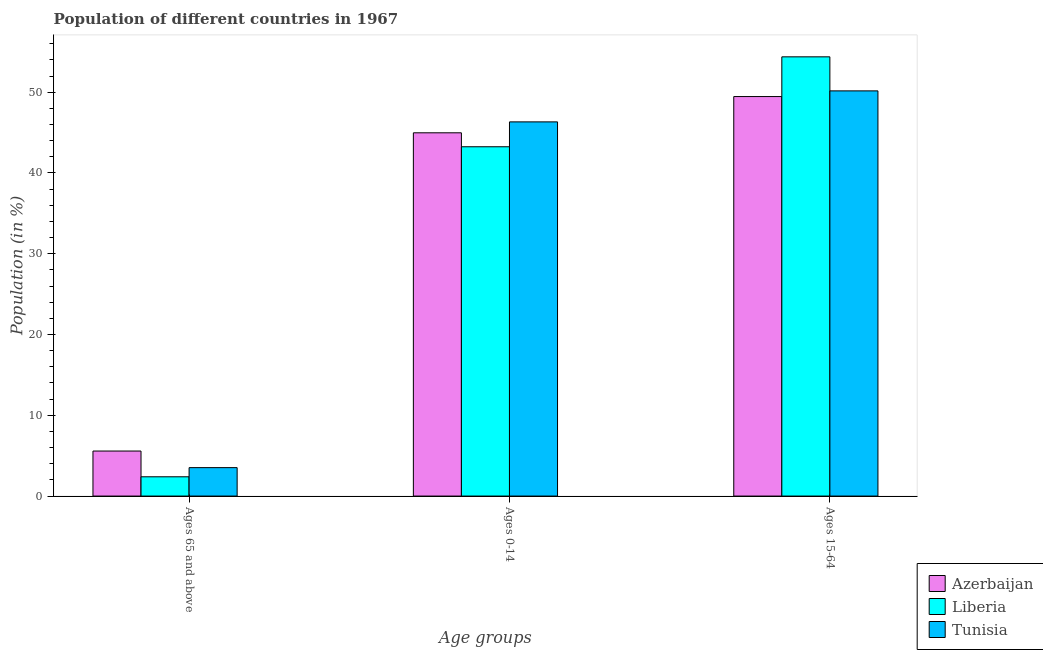How many different coloured bars are there?
Offer a terse response. 3. How many groups of bars are there?
Give a very brief answer. 3. Are the number of bars per tick equal to the number of legend labels?
Your response must be concise. Yes. What is the label of the 1st group of bars from the left?
Your answer should be compact. Ages 65 and above. What is the percentage of population within the age-group 0-14 in Azerbaijan?
Your response must be concise. 44.97. Across all countries, what is the maximum percentage of population within the age-group 15-64?
Give a very brief answer. 54.37. Across all countries, what is the minimum percentage of population within the age-group 0-14?
Provide a succinct answer. 43.24. In which country was the percentage of population within the age-group 15-64 maximum?
Offer a very short reply. Liberia. In which country was the percentage of population within the age-group 0-14 minimum?
Your answer should be very brief. Liberia. What is the total percentage of population within the age-group 0-14 in the graph?
Keep it short and to the point. 134.53. What is the difference between the percentage of population within the age-group 0-14 in Azerbaijan and that in Tunisia?
Keep it short and to the point. -1.35. What is the difference between the percentage of population within the age-group 0-14 in Tunisia and the percentage of population within the age-group of 65 and above in Azerbaijan?
Offer a very short reply. 40.75. What is the average percentage of population within the age-group 15-64 per country?
Make the answer very short. 51.33. What is the difference between the percentage of population within the age-group of 65 and above and percentage of population within the age-group 0-14 in Azerbaijan?
Your answer should be very brief. -39.39. In how many countries, is the percentage of population within the age-group of 65 and above greater than 2 %?
Your answer should be compact. 3. What is the ratio of the percentage of population within the age-group 0-14 in Azerbaijan to that in Liberia?
Your response must be concise. 1.04. Is the percentage of population within the age-group of 65 and above in Tunisia less than that in Liberia?
Your answer should be very brief. No. What is the difference between the highest and the second highest percentage of population within the age-group 15-64?
Your response must be concise. 4.21. What is the difference between the highest and the lowest percentage of population within the age-group of 65 and above?
Give a very brief answer. 3.19. What does the 2nd bar from the left in Ages 0-14 represents?
Provide a short and direct response. Liberia. What does the 1st bar from the right in Ages 0-14 represents?
Your response must be concise. Tunisia. Is it the case that in every country, the sum of the percentage of population within the age-group of 65 and above and percentage of population within the age-group 0-14 is greater than the percentage of population within the age-group 15-64?
Give a very brief answer. No. How many countries are there in the graph?
Offer a terse response. 3. What is the difference between two consecutive major ticks on the Y-axis?
Make the answer very short. 10. Does the graph contain any zero values?
Your answer should be compact. No. Does the graph contain grids?
Make the answer very short. No. Where does the legend appear in the graph?
Provide a short and direct response. Bottom right. What is the title of the graph?
Offer a very short reply. Population of different countries in 1967. Does "Russian Federation" appear as one of the legend labels in the graph?
Offer a terse response. No. What is the label or title of the X-axis?
Your answer should be very brief. Age groups. What is the label or title of the Y-axis?
Offer a very short reply. Population (in %). What is the Population (in %) in Azerbaijan in Ages 65 and above?
Offer a very short reply. 5.57. What is the Population (in %) of Liberia in Ages 65 and above?
Offer a very short reply. 2.39. What is the Population (in %) of Tunisia in Ages 65 and above?
Provide a succinct answer. 3.52. What is the Population (in %) of Azerbaijan in Ages 0-14?
Your response must be concise. 44.97. What is the Population (in %) in Liberia in Ages 0-14?
Make the answer very short. 43.24. What is the Population (in %) in Tunisia in Ages 0-14?
Your response must be concise. 46.32. What is the Population (in %) in Azerbaijan in Ages 15-64?
Your answer should be compact. 49.46. What is the Population (in %) in Liberia in Ages 15-64?
Make the answer very short. 54.37. What is the Population (in %) in Tunisia in Ages 15-64?
Give a very brief answer. 50.16. Across all Age groups, what is the maximum Population (in %) of Azerbaijan?
Offer a very short reply. 49.46. Across all Age groups, what is the maximum Population (in %) of Liberia?
Provide a succinct answer. 54.37. Across all Age groups, what is the maximum Population (in %) of Tunisia?
Your answer should be compact. 50.16. Across all Age groups, what is the minimum Population (in %) in Azerbaijan?
Offer a very short reply. 5.57. Across all Age groups, what is the minimum Population (in %) of Liberia?
Offer a terse response. 2.39. Across all Age groups, what is the minimum Population (in %) in Tunisia?
Make the answer very short. 3.52. What is the total Population (in %) in Azerbaijan in the graph?
Ensure brevity in your answer.  100. What is the total Population (in %) of Liberia in the graph?
Provide a short and direct response. 100. What is the difference between the Population (in %) of Azerbaijan in Ages 65 and above and that in Ages 0-14?
Offer a very short reply. -39.39. What is the difference between the Population (in %) in Liberia in Ages 65 and above and that in Ages 0-14?
Give a very brief answer. -40.86. What is the difference between the Population (in %) of Tunisia in Ages 65 and above and that in Ages 0-14?
Provide a succinct answer. -42.8. What is the difference between the Population (in %) of Azerbaijan in Ages 65 and above and that in Ages 15-64?
Offer a terse response. -43.88. What is the difference between the Population (in %) of Liberia in Ages 65 and above and that in Ages 15-64?
Your answer should be compact. -51.99. What is the difference between the Population (in %) in Tunisia in Ages 65 and above and that in Ages 15-64?
Your answer should be compact. -46.64. What is the difference between the Population (in %) in Azerbaijan in Ages 0-14 and that in Ages 15-64?
Ensure brevity in your answer.  -4.49. What is the difference between the Population (in %) in Liberia in Ages 0-14 and that in Ages 15-64?
Give a very brief answer. -11.13. What is the difference between the Population (in %) in Tunisia in Ages 0-14 and that in Ages 15-64?
Offer a very short reply. -3.84. What is the difference between the Population (in %) of Azerbaijan in Ages 65 and above and the Population (in %) of Liberia in Ages 0-14?
Provide a short and direct response. -37.67. What is the difference between the Population (in %) in Azerbaijan in Ages 65 and above and the Population (in %) in Tunisia in Ages 0-14?
Offer a very short reply. -40.75. What is the difference between the Population (in %) of Liberia in Ages 65 and above and the Population (in %) of Tunisia in Ages 0-14?
Your answer should be compact. -43.94. What is the difference between the Population (in %) of Azerbaijan in Ages 65 and above and the Population (in %) of Liberia in Ages 15-64?
Make the answer very short. -48.8. What is the difference between the Population (in %) in Azerbaijan in Ages 65 and above and the Population (in %) in Tunisia in Ages 15-64?
Your answer should be compact. -44.58. What is the difference between the Population (in %) of Liberia in Ages 65 and above and the Population (in %) of Tunisia in Ages 15-64?
Provide a succinct answer. -47.77. What is the difference between the Population (in %) of Azerbaijan in Ages 0-14 and the Population (in %) of Liberia in Ages 15-64?
Provide a short and direct response. -9.4. What is the difference between the Population (in %) in Azerbaijan in Ages 0-14 and the Population (in %) in Tunisia in Ages 15-64?
Your answer should be very brief. -5.19. What is the difference between the Population (in %) in Liberia in Ages 0-14 and the Population (in %) in Tunisia in Ages 15-64?
Keep it short and to the point. -6.92. What is the average Population (in %) of Azerbaijan per Age groups?
Provide a succinct answer. 33.33. What is the average Population (in %) in Liberia per Age groups?
Provide a short and direct response. 33.33. What is the average Population (in %) in Tunisia per Age groups?
Ensure brevity in your answer.  33.33. What is the difference between the Population (in %) in Azerbaijan and Population (in %) in Liberia in Ages 65 and above?
Your response must be concise. 3.19. What is the difference between the Population (in %) in Azerbaijan and Population (in %) in Tunisia in Ages 65 and above?
Your response must be concise. 2.06. What is the difference between the Population (in %) of Liberia and Population (in %) of Tunisia in Ages 65 and above?
Your response must be concise. -1.13. What is the difference between the Population (in %) of Azerbaijan and Population (in %) of Liberia in Ages 0-14?
Give a very brief answer. 1.73. What is the difference between the Population (in %) of Azerbaijan and Population (in %) of Tunisia in Ages 0-14?
Your answer should be very brief. -1.35. What is the difference between the Population (in %) of Liberia and Population (in %) of Tunisia in Ages 0-14?
Offer a very short reply. -3.08. What is the difference between the Population (in %) in Azerbaijan and Population (in %) in Liberia in Ages 15-64?
Keep it short and to the point. -4.92. What is the difference between the Population (in %) in Azerbaijan and Population (in %) in Tunisia in Ages 15-64?
Make the answer very short. -0.7. What is the difference between the Population (in %) of Liberia and Population (in %) of Tunisia in Ages 15-64?
Make the answer very short. 4.21. What is the ratio of the Population (in %) of Azerbaijan in Ages 65 and above to that in Ages 0-14?
Your response must be concise. 0.12. What is the ratio of the Population (in %) in Liberia in Ages 65 and above to that in Ages 0-14?
Your response must be concise. 0.06. What is the ratio of the Population (in %) of Tunisia in Ages 65 and above to that in Ages 0-14?
Your response must be concise. 0.08. What is the ratio of the Population (in %) in Azerbaijan in Ages 65 and above to that in Ages 15-64?
Your response must be concise. 0.11. What is the ratio of the Population (in %) in Liberia in Ages 65 and above to that in Ages 15-64?
Offer a terse response. 0.04. What is the ratio of the Population (in %) of Tunisia in Ages 65 and above to that in Ages 15-64?
Provide a succinct answer. 0.07. What is the ratio of the Population (in %) of Azerbaijan in Ages 0-14 to that in Ages 15-64?
Your response must be concise. 0.91. What is the ratio of the Population (in %) of Liberia in Ages 0-14 to that in Ages 15-64?
Keep it short and to the point. 0.8. What is the ratio of the Population (in %) of Tunisia in Ages 0-14 to that in Ages 15-64?
Make the answer very short. 0.92. What is the difference between the highest and the second highest Population (in %) of Azerbaijan?
Offer a very short reply. 4.49. What is the difference between the highest and the second highest Population (in %) of Liberia?
Keep it short and to the point. 11.13. What is the difference between the highest and the second highest Population (in %) in Tunisia?
Offer a very short reply. 3.84. What is the difference between the highest and the lowest Population (in %) in Azerbaijan?
Offer a terse response. 43.88. What is the difference between the highest and the lowest Population (in %) of Liberia?
Keep it short and to the point. 51.99. What is the difference between the highest and the lowest Population (in %) of Tunisia?
Give a very brief answer. 46.64. 